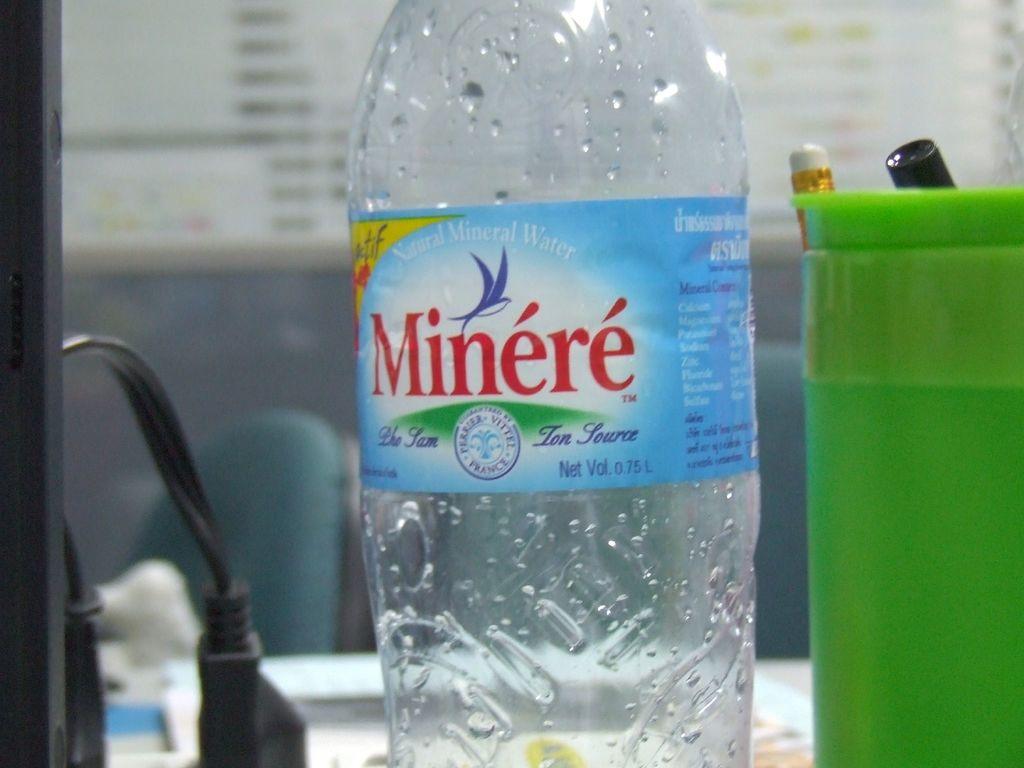Is the water mineral water ?
Offer a very short reply. Yes. What is the brand of mineral water?
Provide a succinct answer. Minere. 